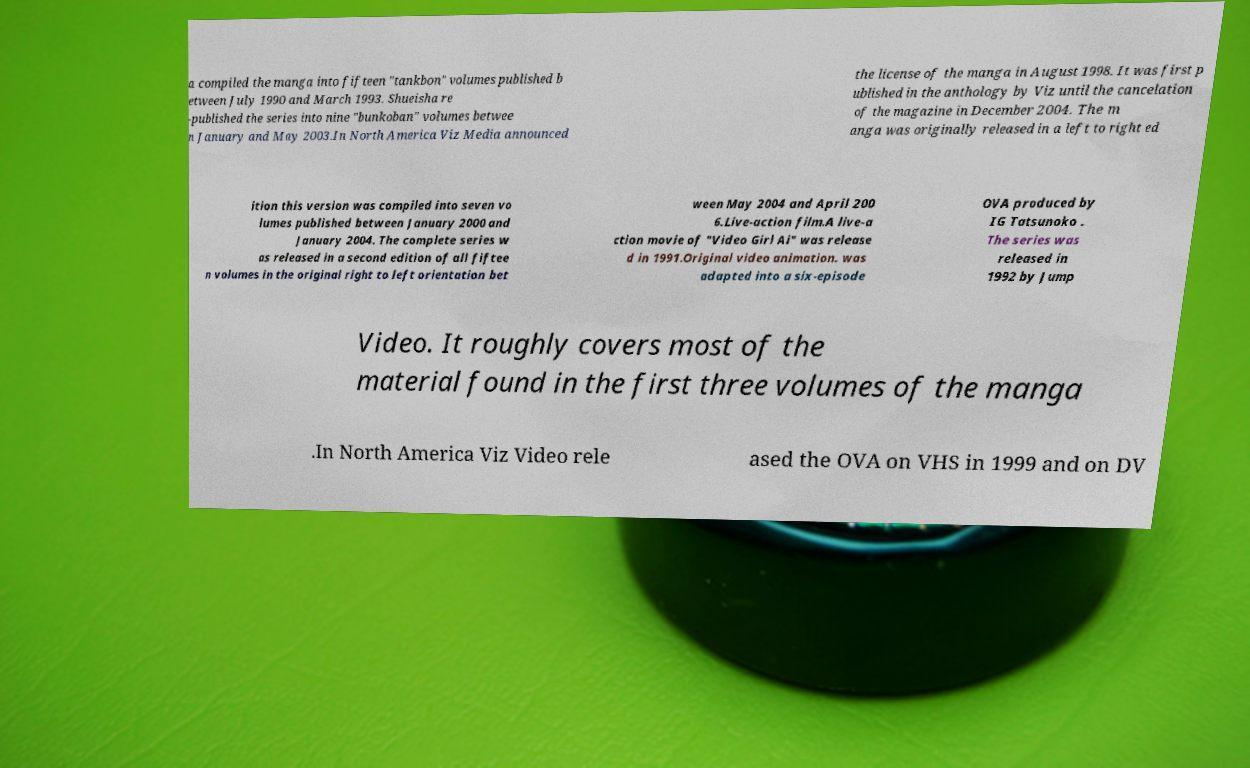Please identify and transcribe the text found in this image. a compiled the manga into fifteen "tankbon" volumes published b etween July 1990 and March 1993. Shueisha re -published the series into nine "bunkoban" volumes betwee n January and May 2003.In North America Viz Media announced the license of the manga in August 1998. It was first p ublished in the anthology by Viz until the cancelation of the magazine in December 2004. The m anga was originally released in a left to right ed ition this version was compiled into seven vo lumes published between January 2000 and January 2004. The complete series w as released in a second edition of all fiftee n volumes in the original right to left orientation bet ween May 2004 and April 200 6.Live-action film.A live-a ction movie of "Video Girl Ai" was release d in 1991.Original video animation. was adapted into a six-episode OVA produced by IG Tatsunoko . The series was released in 1992 by Jump Video. It roughly covers most of the material found in the first three volumes of the manga .In North America Viz Video rele ased the OVA on VHS in 1999 and on DV 